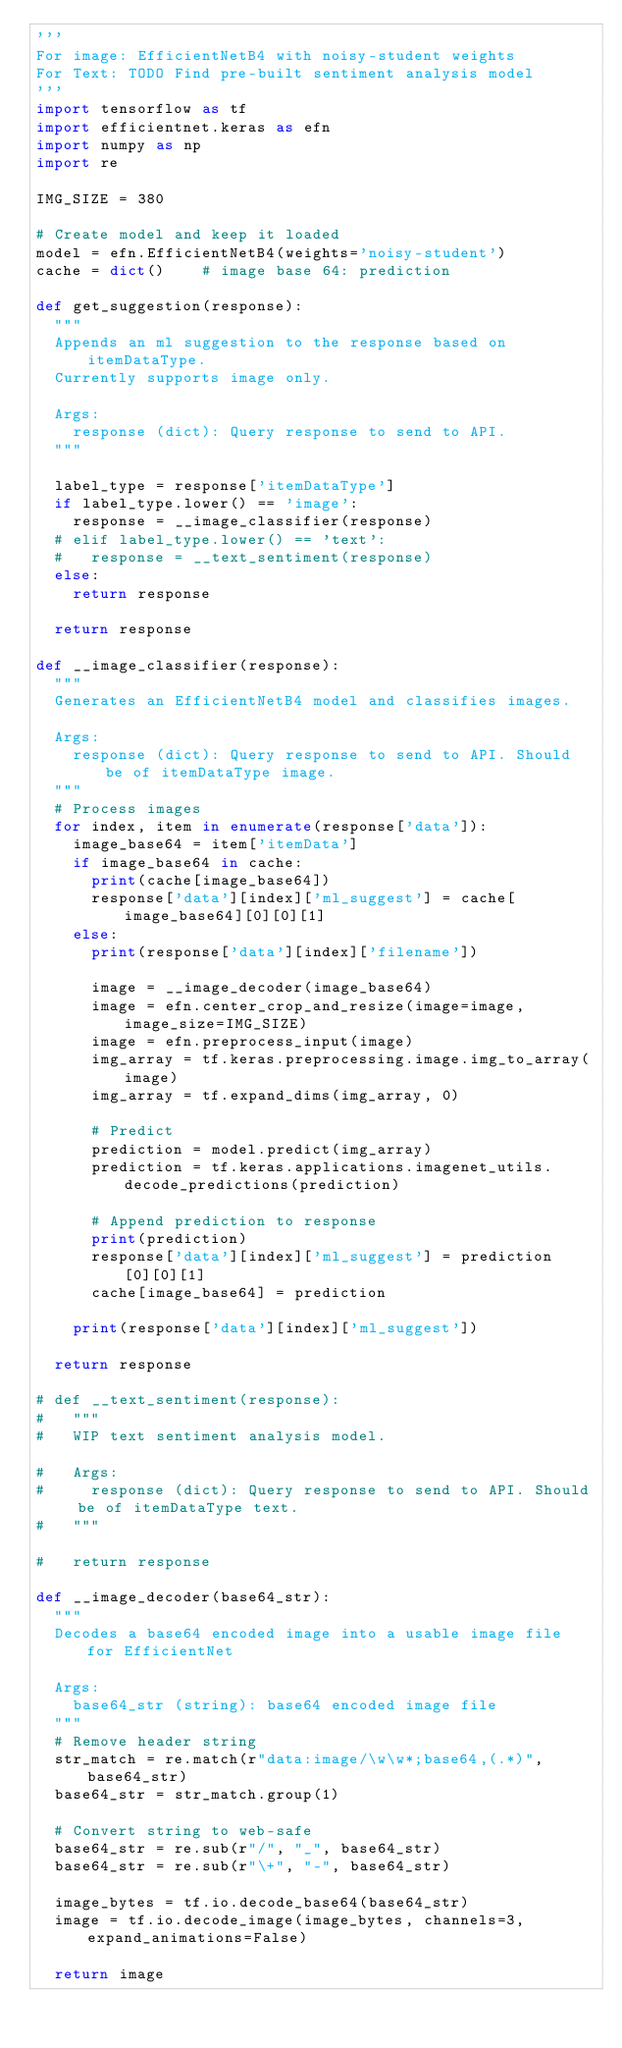<code> <loc_0><loc_0><loc_500><loc_500><_Python_>'''
For image: EfficientNetB4 with noisy-student weights
For Text: TODO Find pre-built sentiment analysis model
'''
import tensorflow as tf
import efficientnet.keras as efn
import numpy as np
import re

IMG_SIZE = 380

# Create model and keep it loaded
model = efn.EfficientNetB4(weights='noisy-student')
cache = dict()		# image base 64: prediction

def get_suggestion(response):
	"""
	Appends an ml suggestion to the response based on itemDataType.
	Currently supports image only.

	Args:
		response (dict): Query response to send to API.
	"""

	label_type = response['itemDataType']
	if label_type.lower() == 'image':
		response = __image_classifier(response)
	# elif label_type.lower() == 'text':
	# 	response = __text_sentiment(response)
	else:
		return response
	
	return response

def __image_classifier(response):
	"""
	Generates an EfficientNetB4 model and classifies images.

	Args:
		response (dict): Query response to send to API. Should be of itemDataType image.
	"""
	# Process images
	for index, item in enumerate(response['data']):
		image_base64 = item['itemData']
		if image_base64 in cache:
			print(cache[image_base64])
			response['data'][index]['ml_suggest'] = cache[image_base64][0][0][1]
		else:
			print(response['data'][index]['filename'])

			image = __image_decoder(image_base64)
			image = efn.center_crop_and_resize(image=image, image_size=IMG_SIZE)
			image = efn.preprocess_input(image)
			img_array = tf.keras.preprocessing.image.img_to_array(image)
			img_array = tf.expand_dims(img_array, 0)

			# Predict
			prediction = model.predict(img_array)
			prediction = tf.keras.applications.imagenet_utils.decode_predictions(prediction)

			# Append prediction to response
			print(prediction)
			response['data'][index]['ml_suggest'] = prediction[0][0][1]
			cache[image_base64] = prediction

		print(response['data'][index]['ml_suggest'])

	return response

# def __text_sentiment(response):
# 	"""
# 	WIP text sentiment analysis model.

# 	Args:
# 		response (dict): Query response to send to API. Should be of itemDataType text.
# 	"""

# 	return response

def __image_decoder(base64_str):
	"""
	Decodes a base64 encoded image into a usable image file for EfficientNet

	Args:
		base64_str (string): base64 encoded image file
	"""
	# Remove header string
	str_match = re.match(r"data:image/\w\w*;base64,(.*)", base64_str)
	base64_str = str_match.group(1)

	# Convert string to web-safe
	base64_str = re.sub(r"/", "_", base64_str)
	base64_str = re.sub(r"\+", "-", base64_str)

	image_bytes = tf.io.decode_base64(base64_str)
	image = tf.io.decode_image(image_bytes, channels=3, expand_animations=False)

	return image</code> 